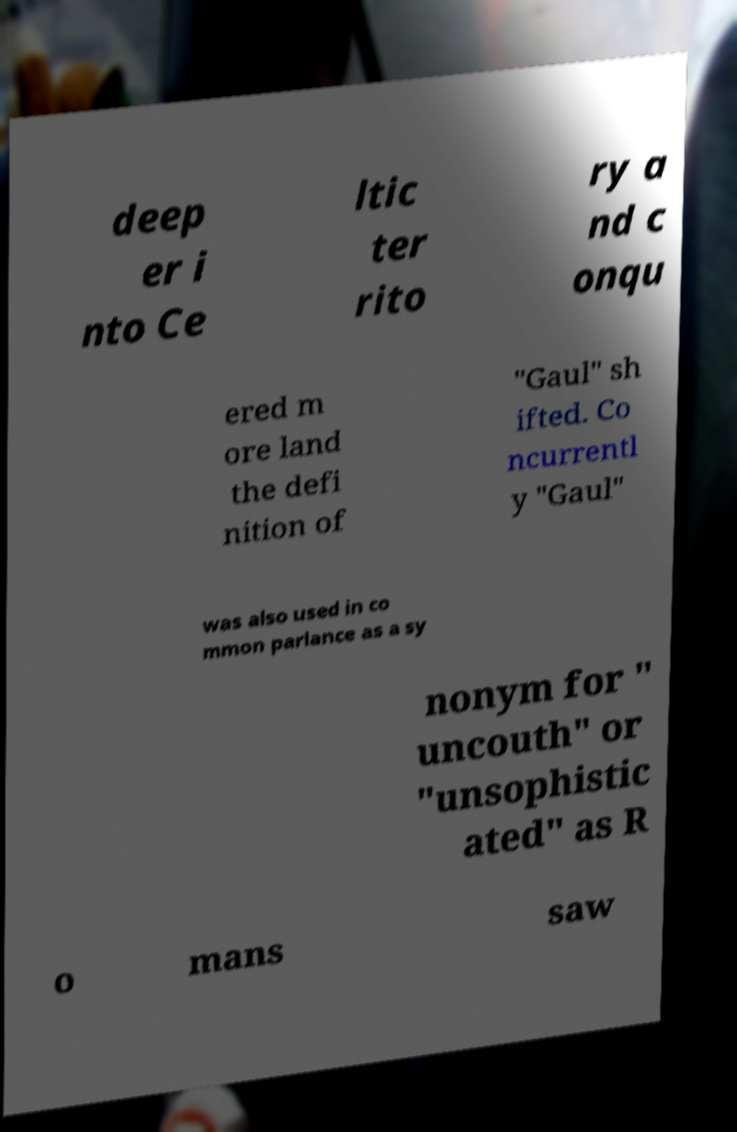I need the written content from this picture converted into text. Can you do that? deep er i nto Ce ltic ter rito ry a nd c onqu ered m ore land the defi nition of "Gaul" sh ifted. Co ncurrentl y "Gaul" was also used in co mmon parlance as a sy nonym for " uncouth" or "unsophistic ated" as R o mans saw 